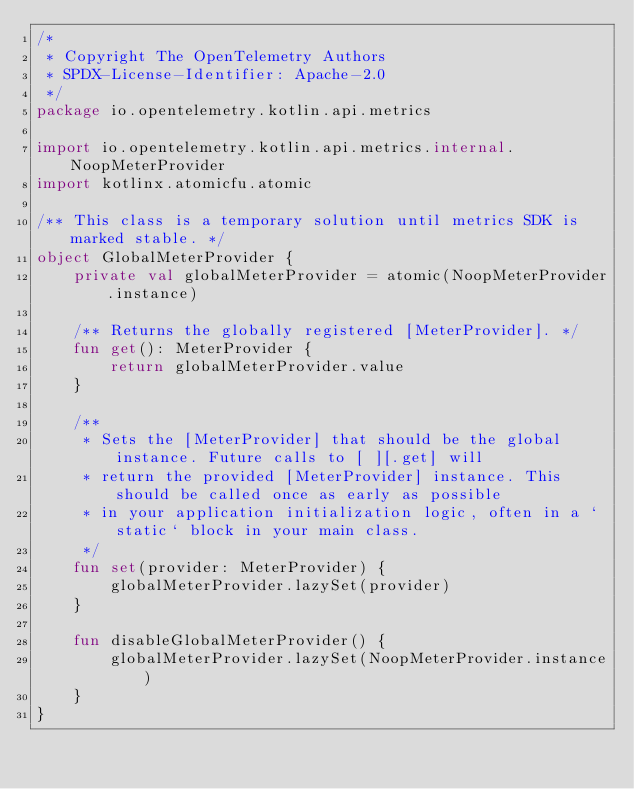Convert code to text. <code><loc_0><loc_0><loc_500><loc_500><_Kotlin_>/*
 * Copyright The OpenTelemetry Authors
 * SPDX-License-Identifier: Apache-2.0
 */
package io.opentelemetry.kotlin.api.metrics

import io.opentelemetry.kotlin.api.metrics.internal.NoopMeterProvider
import kotlinx.atomicfu.atomic

/** This class is a temporary solution until metrics SDK is marked stable. */
object GlobalMeterProvider {
    private val globalMeterProvider = atomic(NoopMeterProvider.instance)

    /** Returns the globally registered [MeterProvider]. */
    fun get(): MeterProvider {
        return globalMeterProvider.value
    }

    /**
     * Sets the [MeterProvider] that should be the global instance. Future calls to [ ][.get] will
     * return the provided [MeterProvider] instance. This should be called once as early as possible
     * in your application initialization logic, often in a `static` block in your main class.
     */
    fun set(provider: MeterProvider) {
        globalMeterProvider.lazySet(provider)
    }

    fun disableGlobalMeterProvider() {
        globalMeterProvider.lazySet(NoopMeterProvider.instance)
    }
}
</code> 